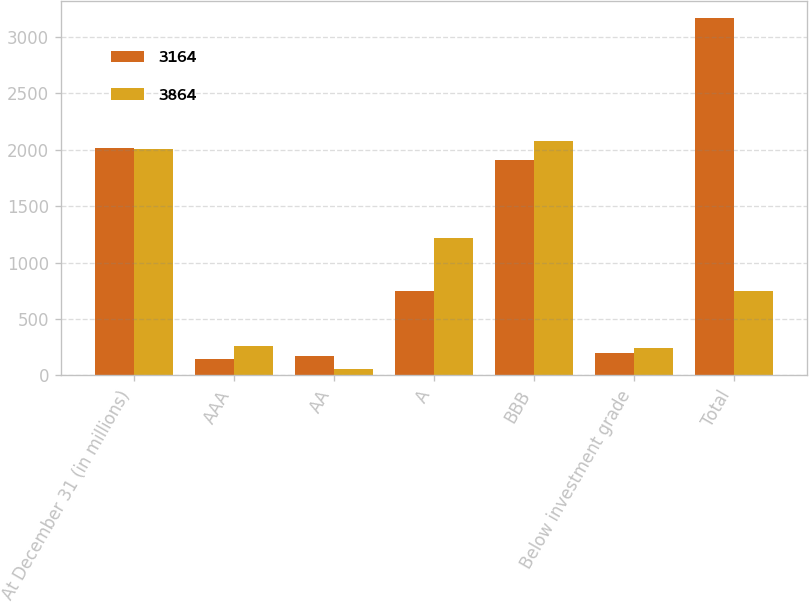Convert chart to OTSL. <chart><loc_0><loc_0><loc_500><loc_500><stacked_bar_chart><ecel><fcel>At December 31 (in millions)<fcel>AAA<fcel>AA<fcel>A<fcel>BBB<fcel>Below investment grade<fcel>Total<nl><fcel>3164<fcel>2012<fcel>145<fcel>168<fcel>745<fcel>1907<fcel>199<fcel>3164<nl><fcel>3864<fcel>2011<fcel>260<fcel>58<fcel>1218<fcel>2081<fcel>247<fcel>745<nl></chart> 